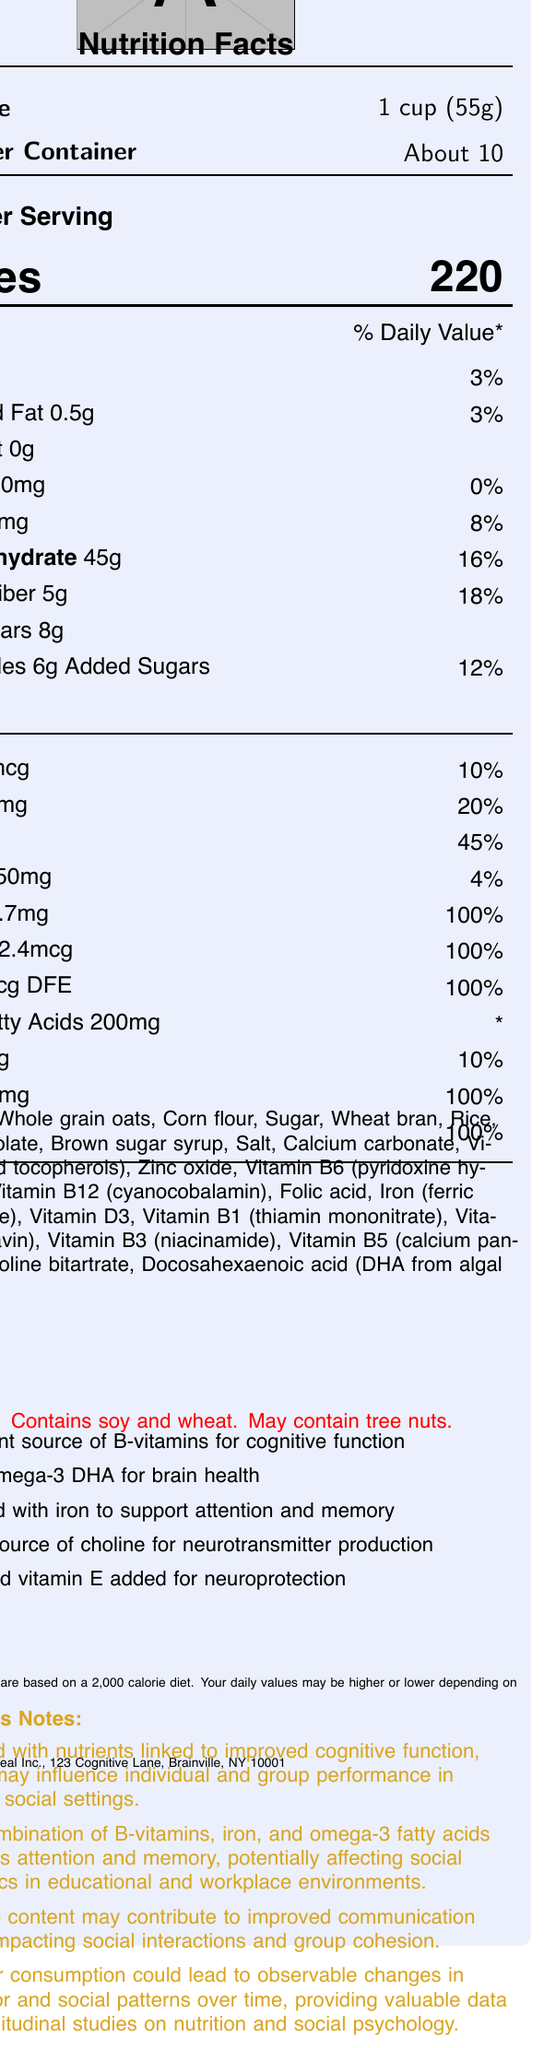what is the serving size? The serving size is clearly listed as 1 cup (55g) in the document.
Answer: 1 cup (55g) how many servings per container? The document mentions that there are about 10 servings per container.
Answer: About 10 how much dietary fiber is in one serving? The document indicates that one serving has 5g of dietary fiber.
Answer: 5g how much cholesterol is in one serving of the cereal? The document states that the cereal contains 0mg of cholesterol per serving.
Answer: 0mg what percentage of the daily value of iron does one serving provide? According to the document, one serving provides 45% of the daily value of iron.
Answer: 45% what is the name of the cereal? A. HealthPlus B. BrainBoost C. CognitionCrunch The document states that the name of the cereal is BrainBoost Cereal.
Answer: B which nutrient in BrainBoost Cereal supports brain health? A. Vitamin C B. Omega-3 DHA C. Sodium D. Potassium The document claims that Omega-3 DHA supports brain health.
Answer: B does the cereal contain any allergens? The document states that the cereal contains soy and wheat and may contain tree nuts.
Answer: Yes what are some of the cognitive benefits associated with the nutrients in the cereal? According to the psychologist's notes, the combination of B-vitamins, iron, and omega-3 fatty acids supports attention and memory.
Answer: Improved attention and memory describe the main idea of the document The document not only lists the nutritional content but also explains how the fortified nutrients can improve cognitive function and impact social dynamics.
Answer: The document provides detailed nutrition information about BrainBoost Cereal, highlighting its micro and macronutrient content and the cognitive benefits of its fortified ingredients. It features product claims, allergen information, manufacturer details, and psychologist notes on the potential behavioral and social impacts of consuming the cereal. how much magnesium does the cereal contain? The document does not provide details on magnesium content.
Answer: Not enough information what is the amount of protein in one serving of BrainBoost Cereal? The document lists that one serving contains 6g of protein.
Answer: 6g which vitamin has the highest daily value percentage in one serving? Each of these vitamins is listed as providing 100% of the daily value in one serving of the cereal.
Answer: Vitamin B6, Vitamin B12, Folate, Vitamin E, Zinc who produces BrainBoost Cereal? The document states that BrainBoost Cereal is produced by NeuroCereal Inc.
Answer: NeuroCereal Inc. what is the main ingredient in the cereal? The first ingredient listed is whole grain oats, indicating it is the primary ingredient.
Answer: Whole grain oats what are the specific claims made about the cognitive benefits of the cereal? The document lists these as specific claims regarding the cognitive benefits of the cereal.
Answer: Excellent source of B-vitamins for cognitive function, With Omega-3 DHA for brain health, Fortified with iron to support attention and memory, Good source of choline for neurotransmitter production, Zinc and vitamin E added for neuroprotection 